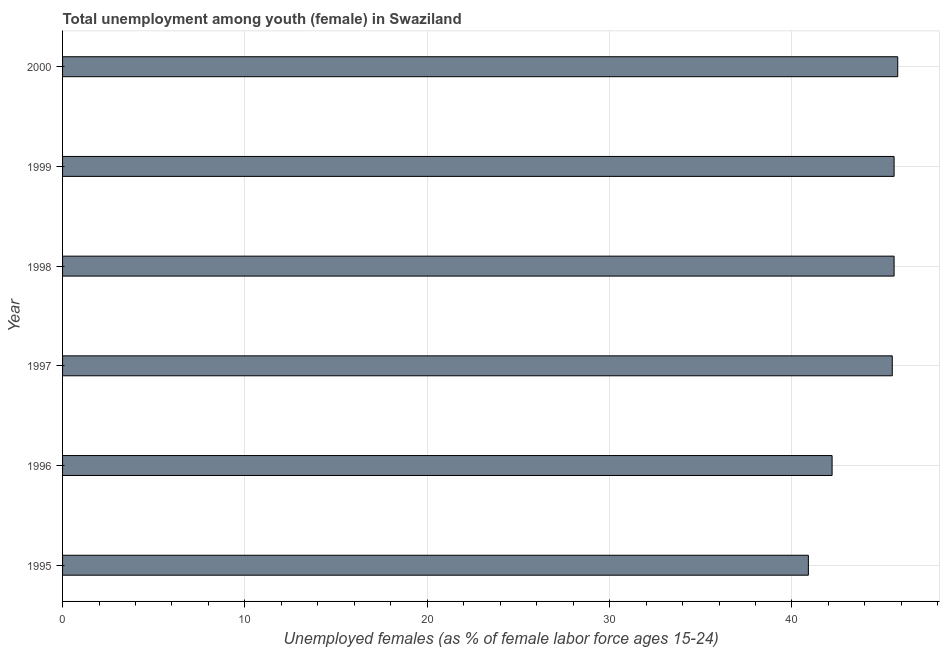What is the title of the graph?
Your response must be concise. Total unemployment among youth (female) in Swaziland. What is the label or title of the X-axis?
Give a very brief answer. Unemployed females (as % of female labor force ages 15-24). What is the label or title of the Y-axis?
Give a very brief answer. Year. What is the unemployed female youth population in 1999?
Provide a succinct answer. 45.6. Across all years, what is the maximum unemployed female youth population?
Your answer should be compact. 45.8. Across all years, what is the minimum unemployed female youth population?
Offer a terse response. 40.9. In which year was the unemployed female youth population maximum?
Your answer should be compact. 2000. In which year was the unemployed female youth population minimum?
Keep it short and to the point. 1995. What is the sum of the unemployed female youth population?
Your answer should be very brief. 265.6. What is the average unemployed female youth population per year?
Ensure brevity in your answer.  44.27. What is the median unemployed female youth population?
Offer a very short reply. 45.55. In how many years, is the unemployed female youth population greater than 32 %?
Your answer should be very brief. 6. What is the ratio of the unemployed female youth population in 1996 to that in 2000?
Your answer should be very brief. 0.92. What is the difference between the highest and the second highest unemployed female youth population?
Offer a terse response. 0.2. In how many years, is the unemployed female youth population greater than the average unemployed female youth population taken over all years?
Ensure brevity in your answer.  4. How many bars are there?
Your answer should be compact. 6. How many years are there in the graph?
Your answer should be very brief. 6. Are the values on the major ticks of X-axis written in scientific E-notation?
Keep it short and to the point. No. What is the Unemployed females (as % of female labor force ages 15-24) of 1995?
Ensure brevity in your answer.  40.9. What is the Unemployed females (as % of female labor force ages 15-24) of 1996?
Offer a very short reply. 42.2. What is the Unemployed females (as % of female labor force ages 15-24) in 1997?
Keep it short and to the point. 45.5. What is the Unemployed females (as % of female labor force ages 15-24) of 1998?
Offer a very short reply. 45.6. What is the Unemployed females (as % of female labor force ages 15-24) in 1999?
Make the answer very short. 45.6. What is the Unemployed females (as % of female labor force ages 15-24) in 2000?
Provide a succinct answer. 45.8. What is the difference between the Unemployed females (as % of female labor force ages 15-24) in 1995 and 1997?
Make the answer very short. -4.6. What is the difference between the Unemployed females (as % of female labor force ages 15-24) in 1995 and 1999?
Your answer should be very brief. -4.7. What is the difference between the Unemployed females (as % of female labor force ages 15-24) in 1996 and 1997?
Make the answer very short. -3.3. What is the difference between the Unemployed females (as % of female labor force ages 15-24) in 1996 and 1998?
Your response must be concise. -3.4. What is the difference between the Unemployed females (as % of female labor force ages 15-24) in 1996 and 1999?
Offer a very short reply. -3.4. What is the difference between the Unemployed females (as % of female labor force ages 15-24) in 1996 and 2000?
Offer a terse response. -3.6. What is the difference between the Unemployed females (as % of female labor force ages 15-24) in 1997 and 1999?
Make the answer very short. -0.1. What is the difference between the Unemployed females (as % of female labor force ages 15-24) in 1999 and 2000?
Make the answer very short. -0.2. What is the ratio of the Unemployed females (as % of female labor force ages 15-24) in 1995 to that in 1996?
Your answer should be compact. 0.97. What is the ratio of the Unemployed females (as % of female labor force ages 15-24) in 1995 to that in 1997?
Ensure brevity in your answer.  0.9. What is the ratio of the Unemployed females (as % of female labor force ages 15-24) in 1995 to that in 1998?
Provide a short and direct response. 0.9. What is the ratio of the Unemployed females (as % of female labor force ages 15-24) in 1995 to that in 1999?
Your answer should be very brief. 0.9. What is the ratio of the Unemployed females (as % of female labor force ages 15-24) in 1995 to that in 2000?
Keep it short and to the point. 0.89. What is the ratio of the Unemployed females (as % of female labor force ages 15-24) in 1996 to that in 1997?
Provide a succinct answer. 0.93. What is the ratio of the Unemployed females (as % of female labor force ages 15-24) in 1996 to that in 1998?
Keep it short and to the point. 0.93. What is the ratio of the Unemployed females (as % of female labor force ages 15-24) in 1996 to that in 1999?
Provide a short and direct response. 0.93. What is the ratio of the Unemployed females (as % of female labor force ages 15-24) in 1996 to that in 2000?
Provide a short and direct response. 0.92. What is the ratio of the Unemployed females (as % of female labor force ages 15-24) in 1998 to that in 1999?
Provide a short and direct response. 1. What is the ratio of the Unemployed females (as % of female labor force ages 15-24) in 1998 to that in 2000?
Provide a short and direct response. 1. What is the ratio of the Unemployed females (as % of female labor force ages 15-24) in 1999 to that in 2000?
Offer a terse response. 1. 